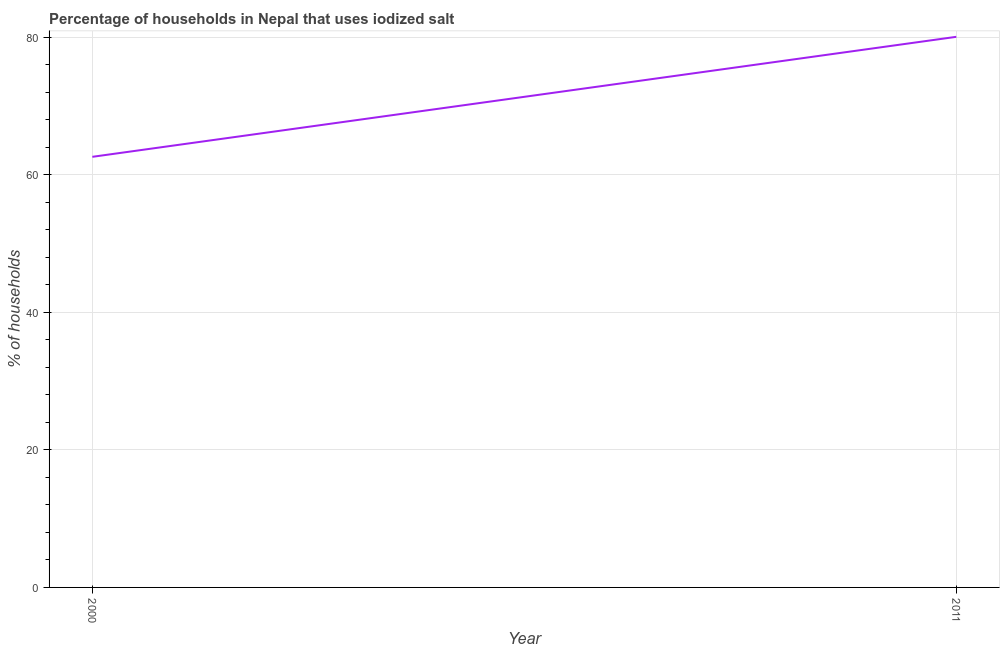What is the percentage of households where iodized salt is consumed in 2011?
Make the answer very short. 80.05. Across all years, what is the maximum percentage of households where iodized salt is consumed?
Ensure brevity in your answer.  80.05. Across all years, what is the minimum percentage of households where iodized salt is consumed?
Your answer should be very brief. 62.6. In which year was the percentage of households where iodized salt is consumed maximum?
Provide a succinct answer. 2011. In which year was the percentage of households where iodized salt is consumed minimum?
Offer a very short reply. 2000. What is the sum of the percentage of households where iodized salt is consumed?
Provide a succinct answer. 142.65. What is the difference between the percentage of households where iodized salt is consumed in 2000 and 2011?
Offer a very short reply. -17.45. What is the average percentage of households where iodized salt is consumed per year?
Your response must be concise. 71.32. What is the median percentage of households where iodized salt is consumed?
Your answer should be very brief. 71.32. In how many years, is the percentage of households where iodized salt is consumed greater than 40 %?
Your answer should be very brief. 2. Do a majority of the years between 2011 and 2000 (inclusive) have percentage of households where iodized salt is consumed greater than 56 %?
Keep it short and to the point. No. What is the ratio of the percentage of households where iodized salt is consumed in 2000 to that in 2011?
Offer a very short reply. 0.78. What is the difference between two consecutive major ticks on the Y-axis?
Make the answer very short. 20. What is the title of the graph?
Provide a succinct answer. Percentage of households in Nepal that uses iodized salt. What is the label or title of the X-axis?
Your answer should be very brief. Year. What is the label or title of the Y-axis?
Your answer should be very brief. % of households. What is the % of households of 2000?
Ensure brevity in your answer.  62.6. What is the % of households in 2011?
Your answer should be compact. 80.05. What is the difference between the % of households in 2000 and 2011?
Keep it short and to the point. -17.45. What is the ratio of the % of households in 2000 to that in 2011?
Your response must be concise. 0.78. 